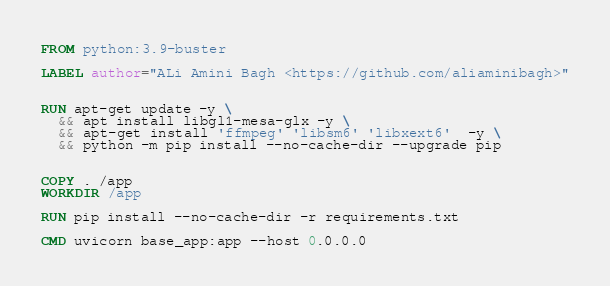<code> <loc_0><loc_0><loc_500><loc_500><_Dockerfile_>FROM python:3.9-buster

LABEL author="ALi Amini Bagh <https://github.com/aliaminibagh>"


RUN apt-get update -y \
  && apt install libgl1-mesa-glx -y \
  && apt-get install 'ffmpeg' 'libsm6' 'libxext6'  -y \
  && python -m pip install --no-cache-dir --upgrade pip


COPY . /app
WORKDIR /app

RUN pip install --no-cache-dir -r requirements.txt

CMD uvicorn base_app:app --host 0.0.0.0</code> 